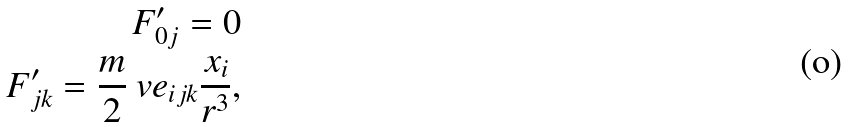<formula> <loc_0><loc_0><loc_500><loc_500>F ^ { \prime } _ { 0 j } = 0 \\ F ^ { \prime } _ { j k } = \frac { m } { 2 } \ v e _ { i j k } \frac { x _ { i } } { r ^ { 3 } } ,</formula> 